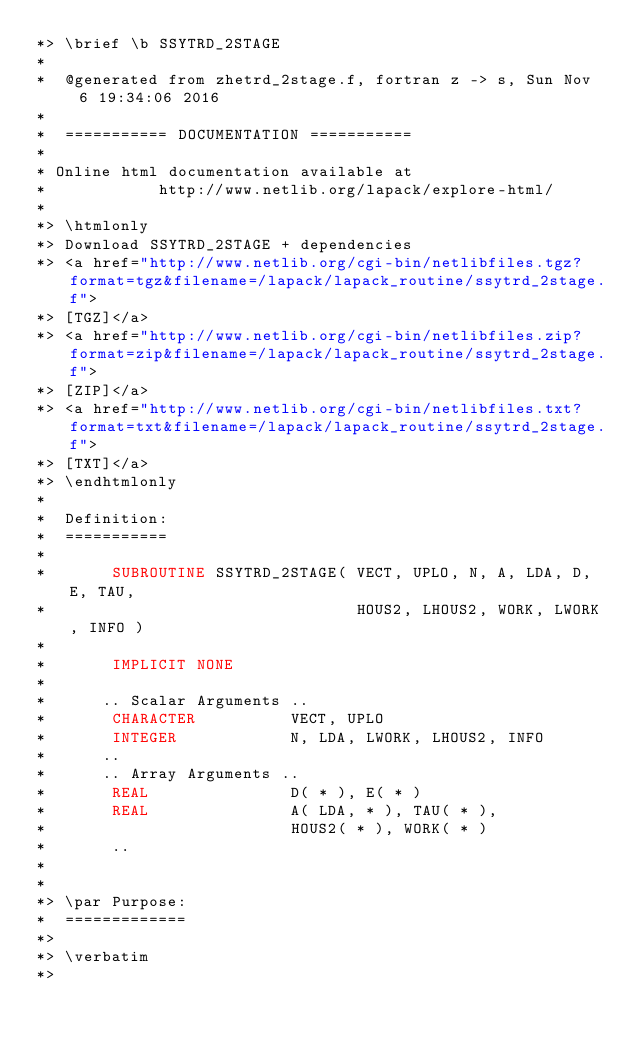Convert code to text. <code><loc_0><loc_0><loc_500><loc_500><_FORTRAN_>*> \brief \b SSYTRD_2STAGE
*
*  @generated from zhetrd_2stage.f, fortran z -> s, Sun Nov  6 19:34:06 2016
*
*  =========== DOCUMENTATION ===========
*
* Online html documentation available at 
*            http://www.netlib.org/lapack/explore-html/ 
*
*> \htmlonly
*> Download SSYTRD_2STAGE + dependencies 
*> <a href="http://www.netlib.org/cgi-bin/netlibfiles.tgz?format=tgz&filename=/lapack/lapack_routine/ssytrd_2stage.f"> 
*> [TGZ]</a> 
*> <a href="http://www.netlib.org/cgi-bin/netlibfiles.zip?format=zip&filename=/lapack/lapack_routine/ssytrd_2stage.f"> 
*> [ZIP]</a> 
*> <a href="http://www.netlib.org/cgi-bin/netlibfiles.txt?format=txt&filename=/lapack/lapack_routine/ssytrd_2stage.f"> 
*> [TXT]</a>
*> \endhtmlonly 
*
*  Definition:
*  ===========
*
*       SUBROUTINE SSYTRD_2STAGE( VECT, UPLO, N, A, LDA, D, E, TAU, 
*                                 HOUS2, LHOUS2, WORK, LWORK, INFO )
*
*       IMPLICIT NONE
*
*      .. Scalar Arguments ..
*       CHARACTER          VECT, UPLO
*       INTEGER            N, LDA, LWORK, LHOUS2, INFO
*      ..
*      .. Array Arguments ..
*       REAL               D( * ), E( * )
*       REAL               A( LDA, * ), TAU( * ),
*                          HOUS2( * ), WORK( * )
*       ..
*  
*
*> \par Purpose:
*  =============
*>
*> \verbatim
*></code> 